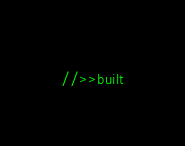Convert code to text. <code><loc_0><loc_0><loc_500><loc_500><_JavaScript_>//>>built</code> 